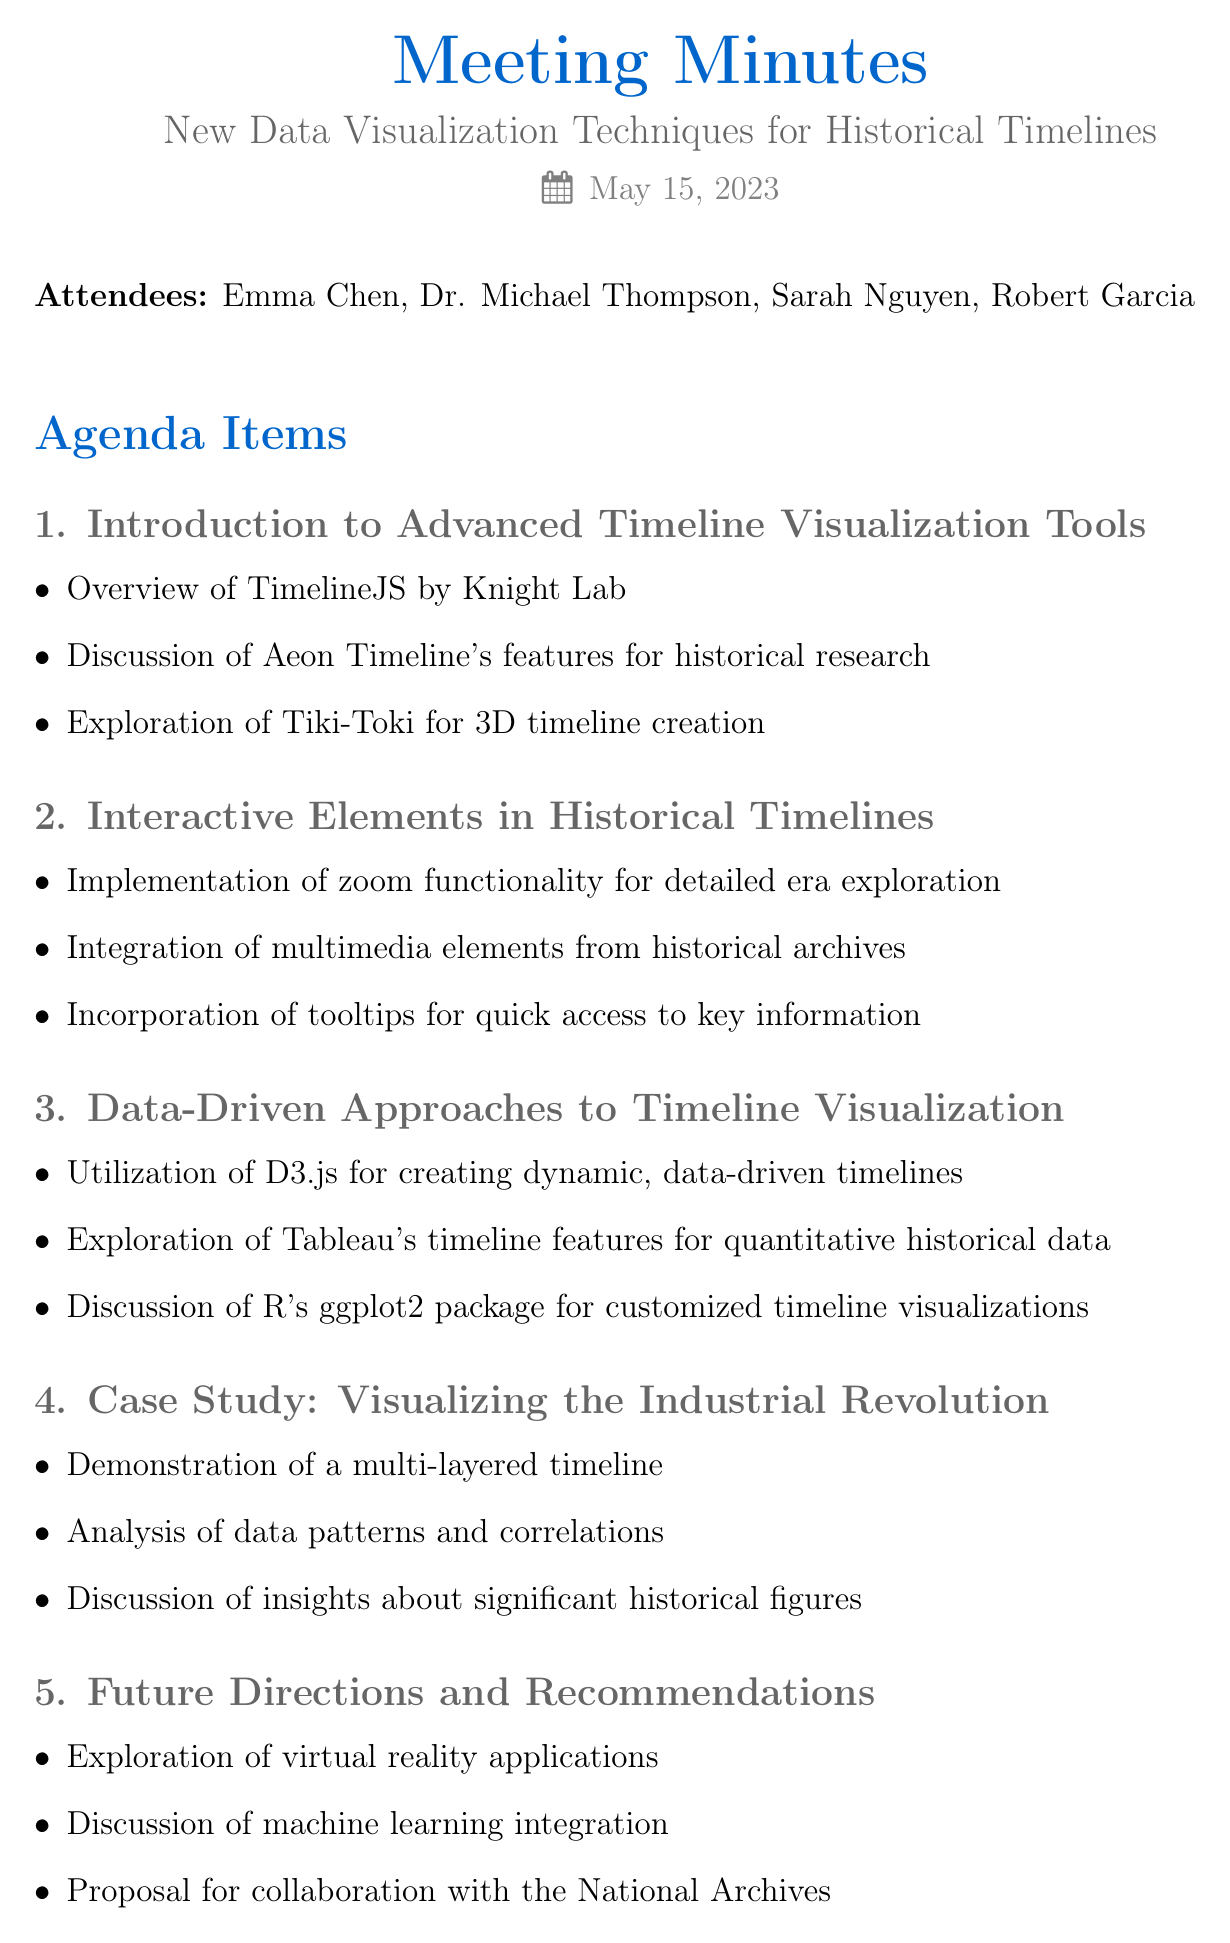what is the meeting title? The meeting title is the main subject of the document, which identifies the focus of the meeting.
Answer: New Data Visualization Techniques for Historical Timelines who is the historian attending the meeting? The document lists the attendees and specifies their roles.
Answer: Dr. Michael Thompson how many agenda items are listed in the document? The number of agenda items is presented in a list format under "Agenda Items."
Answer: Five what technique was proposed for immersive historical timeline experiences? The document includes recommendations for future developments in visualization techniques.
Answer: Virtual reality applications which data visualization tool was discussed for creating dynamic timelines? The agenda item mentions specific tools and their applications in data visualization.
Answer: D3.js who is responsible for preparing a tutorial on D3.js? The action items assign specific tasks to individuals, detailing their responsibilities.
Answer: Robert what feature does Aeon Timeline offer for historical research? The agenda points under "Introduction to Advanced Timeline Visualization Tools" describe features of various tools.
Answer: Historical research what type of elements are recommended for integration into historical timelines? This is mentioned in the agenda discussing interactive elements for enhancing user engagement.
Answer: Multimedia elements what is one of the key historical figures discussed in the case study? The case study highlights significant historical figures associated with the period in question.
Answer: James Watt 